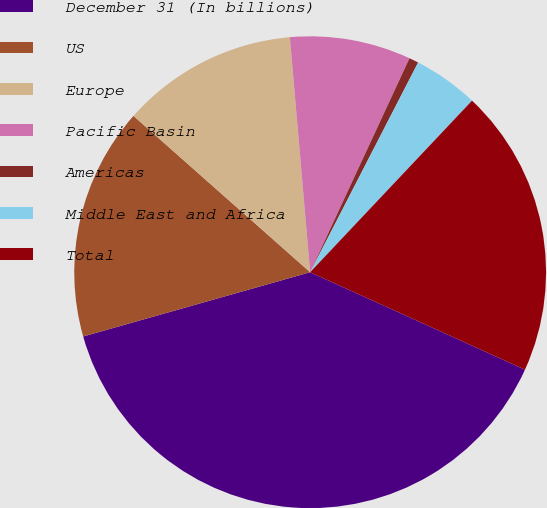<chart> <loc_0><loc_0><loc_500><loc_500><pie_chart><fcel>December 31 (In billions)<fcel>US<fcel>Europe<fcel>Pacific Basin<fcel>Americas<fcel>Middle East and Africa<fcel>Total<nl><fcel>38.83%<fcel>15.92%<fcel>12.1%<fcel>8.29%<fcel>0.65%<fcel>4.47%<fcel>19.74%<nl></chart> 